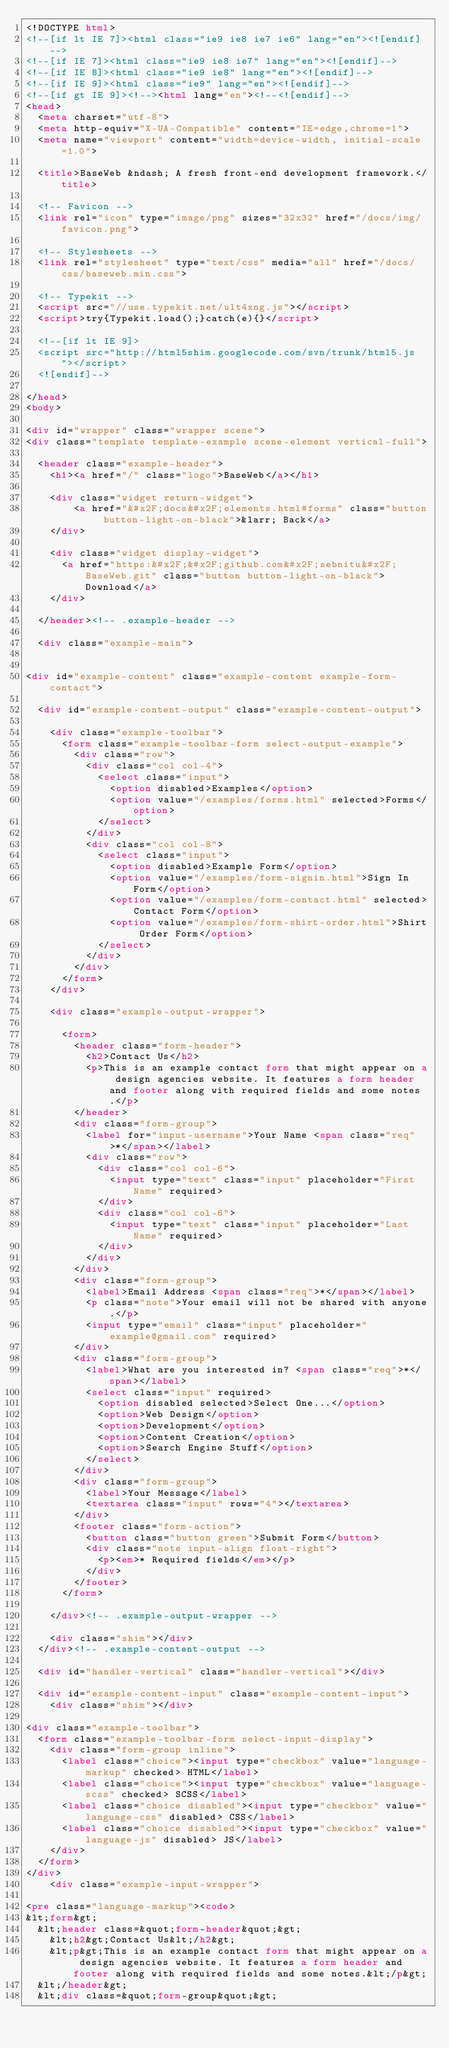<code> <loc_0><loc_0><loc_500><loc_500><_HTML_><!DOCTYPE html>
<!--[if lt IE 7]><html class="ie9 ie8 ie7 ie6" lang="en"><![endif]-->
<!--[if IE 7]><html class="ie9 ie8 ie7" lang="en"><![endif]-->
<!--[if IE 8]><html class="ie9 ie8" lang="en"><![endif]-->
<!--[if IE 9]><html class="ie9" lang="en"><![endif]-->
<!--[if gt IE 9]><!--><html lang="en"><!--<![endif]-->
<head>
  <meta charset="utf-8">
  <meta http-equiv="X-UA-Compatible" content="IE=edge,chrome=1">
  <meta name="viewport" content="width=device-width, initial-scale=1.0">
  
  <title>BaseWeb &ndash; A fresh front-end development framework.</title>
  
  <!-- Favicon -->
  <link rel="icon" type="image/png" sizes="32x32" href="/docs/img/favicon.png">
    
  <!-- Stylesheets -->
  <link rel="stylesheet" type="text/css" media="all" href="/docs/css/baseweb.min.css">
  
  <!-- Typekit -->
  <script src="//use.typekit.net/ult4xng.js"></script>
  <script>try{Typekit.load();}catch(e){}</script>
  
  <!--[if lt IE 9]>
  <script src="http://html5shim.googlecode.com/svn/trunk/html5.js"></script>
  <![endif]-->
  
</head>
<body>
  
<div id="wrapper" class="wrapper scene">
<div class="template template-example scene-element vertical-full">

  <header class="example-header">
    <h1><a href="/" class="logo">BaseWeb</a></h1>
    
    <div class="widget return-widget">
        <a href="&#x2F;docs&#x2F;elements.html#forms" class="button button-light-on-black">&larr; Back</a>
    </div>
    
    <div class="widget display-widget">
      <a href="https:&#x2F;&#x2F;github.com&#x2F;sebnitu&#x2F;BaseWeb.git" class="button button-light-on-black">Download</a>
    </div>
    
  </header><!-- .example-header -->
  
  <div class="example-main">
    

<div id="example-content" class="example-content example-form-contact">
  
  <div id="example-content-output" class="example-content-output">
     
    <div class="example-toolbar">
      <form class="example-toolbar-form select-output-example">
        <div class="row">
          <div class="col col-4">
            <select class="input">
              <option disabled>Examples</option>
              <option value="/examples/forms.html" selected>Forms</option>
            </select>
          </div>
          <div class="col col-8">
            <select class="input">
              <option disabled>Example Form</option>
              <option value="/examples/form-signin.html">Sign In Form</option>
              <option value="/examples/form-contact.html" selected>Contact Form</option>
              <option value="/examples/form-shirt-order.html">Shirt Order Form</option>
            </select>
          </div>
        </div>
      </form>
    </div>
    
    <div class="example-output-wrapper">
    
      <form>
        <header class="form-header">
          <h2>Contact Us</h2>
          <p>This is an example contact form that might appear on a design agencies website. It features a form header and footer along with required fields and some notes.</p>
        </header>
        <div class="form-group">
          <label for="input-username">Your Name <span class="req">*</span></label>
          <div class="row">
            <div class="col col-6">
              <input type="text" class="input" placeholder="First Name" required>
            </div>
            <div class="col col-6">
              <input type="text" class="input" placeholder="Last Name" required>
            </div>
          </div>
        </div>
        <div class="form-group">
          <label>Email Address <span class="req">*</span></label>
          <p class="note">Your email will not be shared with anyone.</p>
          <input type="email" class="input" placeholder="example@gmail.com" required>
        </div>
        <div class="form-group">
          <label>What are you interested in? <span class="req">*</span></label>
          <select class="input" required>
            <option disabled selected>Select One...</option>
            <option>Web Design</option>
            <option>Development</option>
            <option>Content Creation</option>
            <option>Search Engine Stuff</option>
          </select>
        </div>
        <div class="form-group">
          <label>Your Message</label>
          <textarea class="input" rows="4"></textarea>
        </div>
        <footer class="form-action">
          <button class="button green">Submit Form</button>
          <div class="note input-align float-right">
            <p><em>* Required fields</em></p>
          </div>
        </footer>
      </form>
    
    </div><!-- .example-output-wrapper -->
    
    <div class="shim"></div>
  </div><!-- .example-content-output -->
  
  <div id="handler-vertical" class="handler-vertical"></div>
  
  <div id="example-content-input" class="example-content-input">
    <div class="shim"></div>
    
<div class="example-toolbar">
  <form class="example-toolbar-form select-input-display">
    <div class="form-group inline">
      <label class="choice"><input type="checkbox" value="language-markup" checked> HTML</label>
      <label class="choice"><input type="checkbox" value="language-scss" checked> SCSS</label>
      <label class="choice disabled"><input type="checkbox" value="language-css" disabled> CSS</label>
      <label class="choice disabled"><input type="checkbox" value="language-js" disabled> JS</label>
    </div>
  </form>
</div>    
    <div class="example-input-wrapper">
      
<pre class="language-markup"><code>
&lt;form&gt;
  &lt;header class=&quot;form-header&quot;&gt;
    &lt;h2&gt;Contact Us&lt;/h2&gt;
    &lt;p&gt;This is an example contact form that might appear on a design agencies website. It features a form header and footer along with required fields and some notes.&lt;/p&gt;
  &lt;/header&gt;
  &lt;div class=&quot;form-group&quot;&gt;</code> 